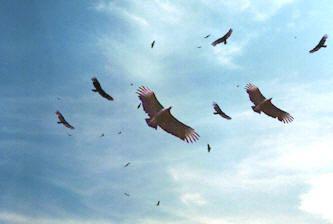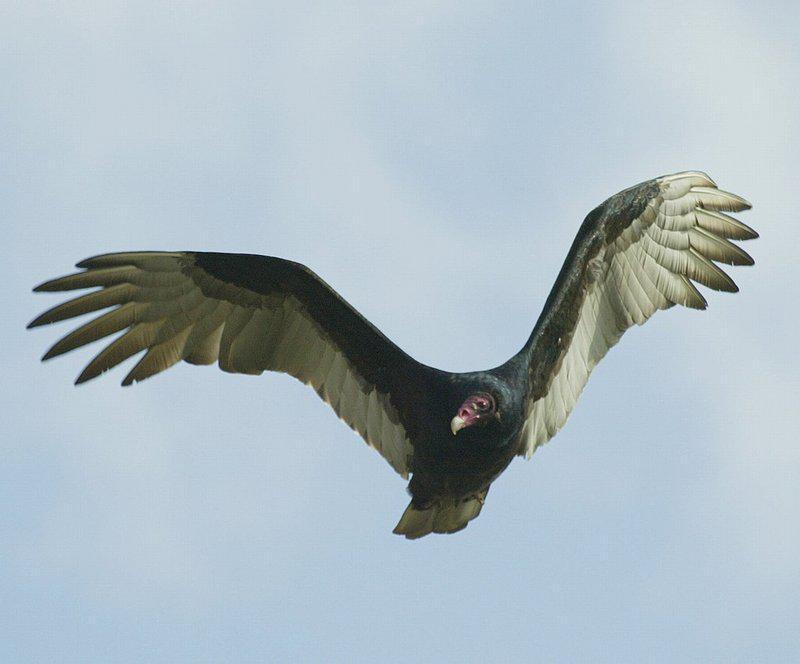The first image is the image on the left, the second image is the image on the right. For the images displayed, is the sentence "Each image includes a vulture with outspread wings, and one image contains a single vulture that is in mid-air." factually correct? Answer yes or no. Yes. The first image is the image on the left, the second image is the image on the right. For the images shown, is this caption "One image contains more than four vultures on a tree that is at least mostly bare, and the other contains a single vulture." true? Answer yes or no. No. 